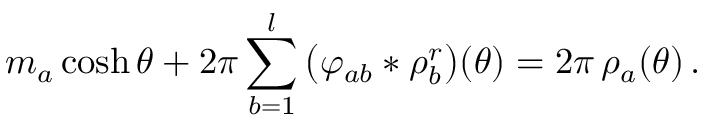<formula> <loc_0><loc_0><loc_500><loc_500>m _ { a } \cosh \theta + 2 \pi \sum _ { b = 1 } ^ { l } \, \left ( \varphi _ { a b } * \rho _ { b } ^ { r } \right ) ( \theta ) = 2 \pi \, \rho _ { a } ( \theta ) \, .</formula> 